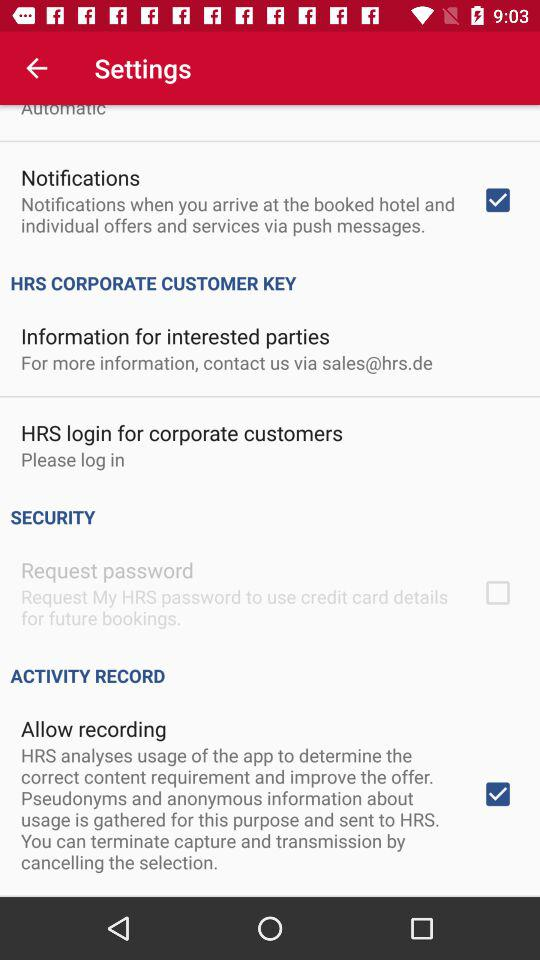What is the status of "Allow recording" setting? The status of "Allow recording" setting is "on". 